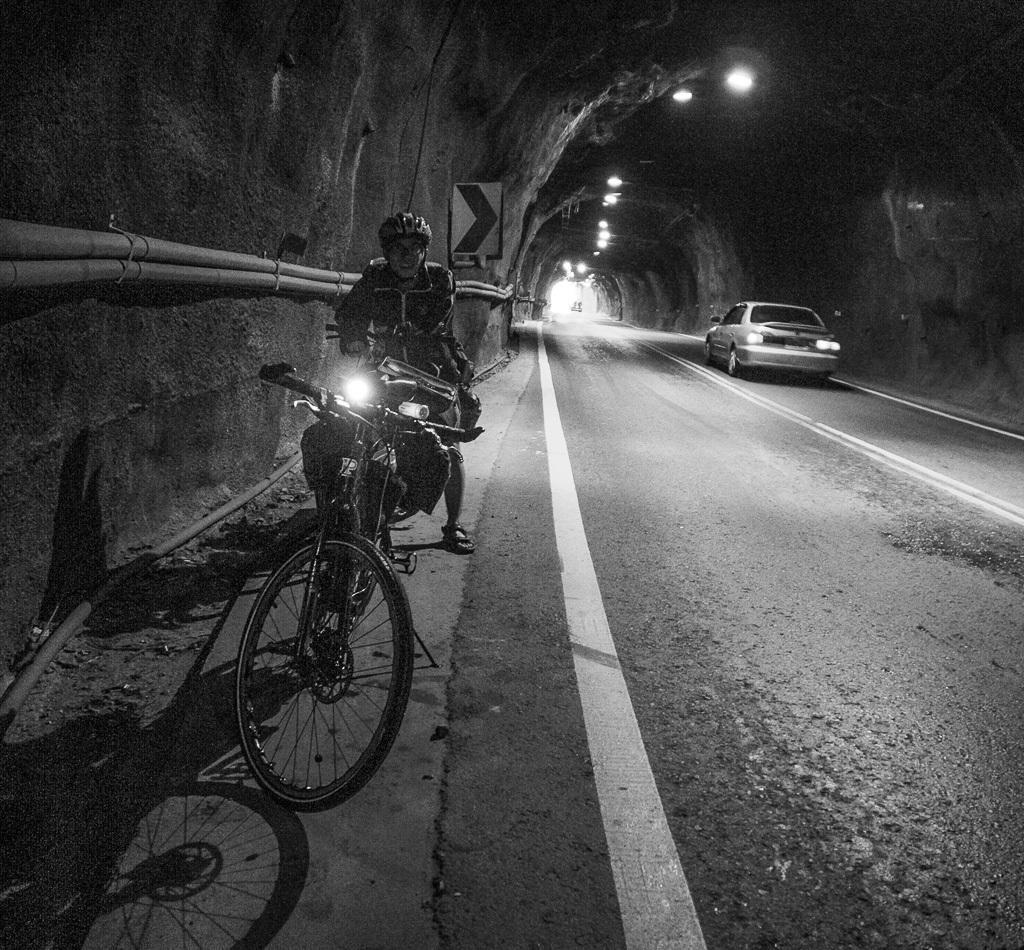Can you describe this image briefly? A man parked vehicle at side of road. He wears a helmet. There is a bicycle in front of him. The road is passing through a tunnel. The tunnel is illuminated with some lights. A car is passing through the tunnel. 